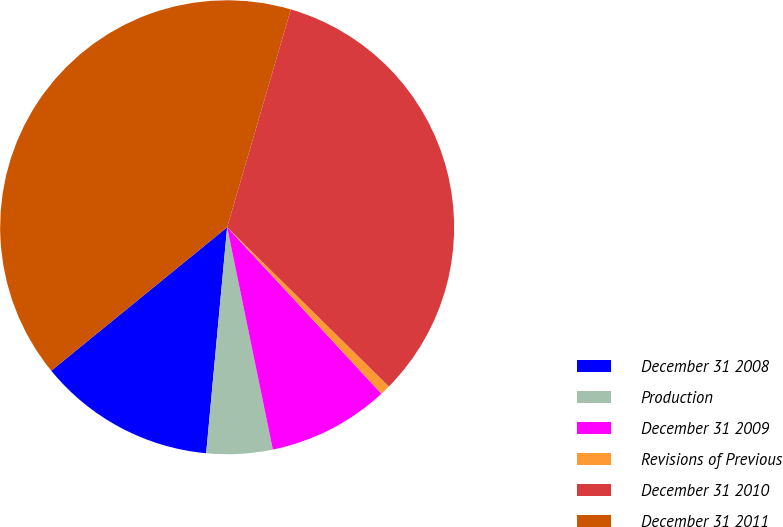Convert chart. <chart><loc_0><loc_0><loc_500><loc_500><pie_chart><fcel>December 31 2008<fcel>Production<fcel>December 31 2009<fcel>Revisions of Previous<fcel>December 31 2010<fcel>December 31 2011<nl><fcel>12.64%<fcel>4.7%<fcel>8.67%<fcel>0.73%<fcel>32.85%<fcel>40.42%<nl></chart> 